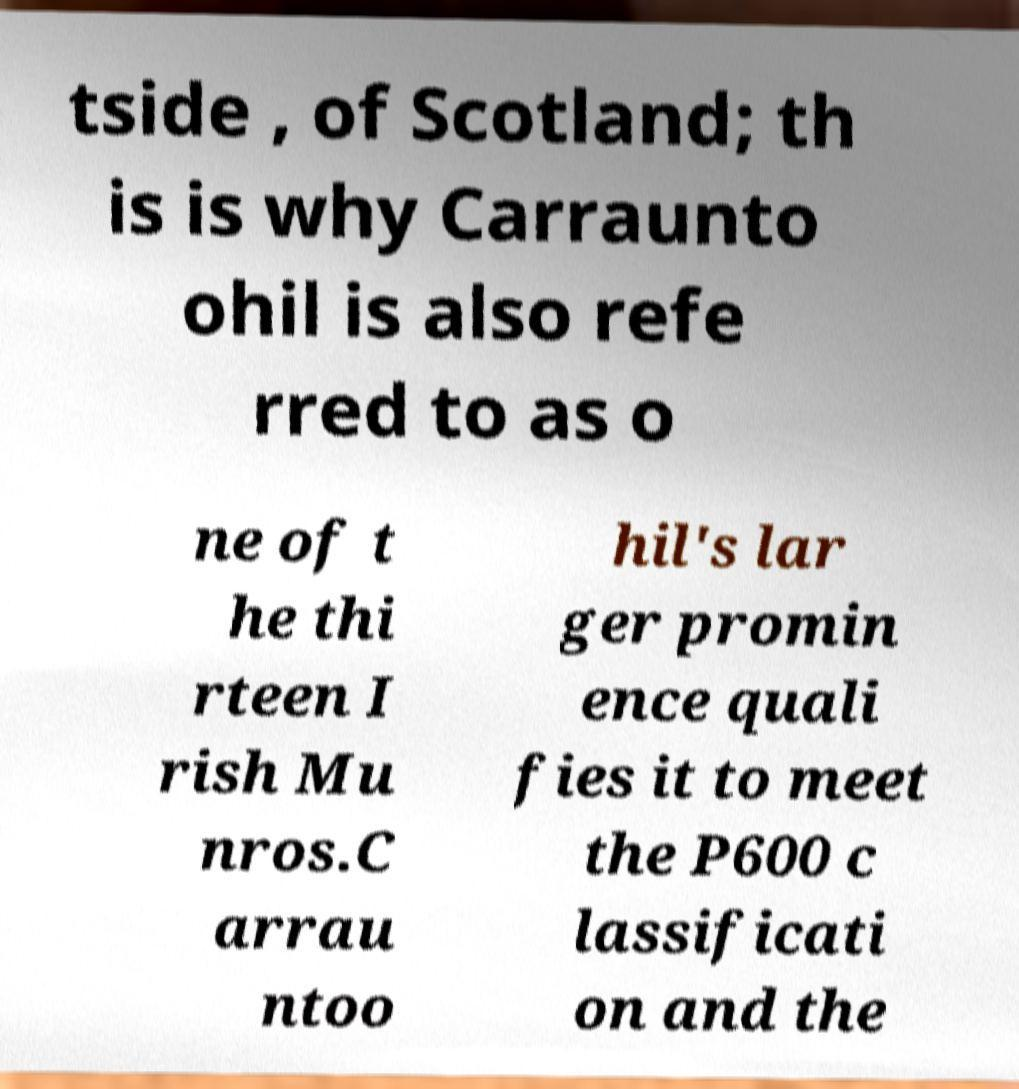For documentation purposes, I need the text within this image transcribed. Could you provide that? tside , of Scotland; th is is why Carraunto ohil is also refe rred to as o ne of t he thi rteen I rish Mu nros.C arrau ntoo hil's lar ger promin ence quali fies it to meet the P600 c lassificati on and the 